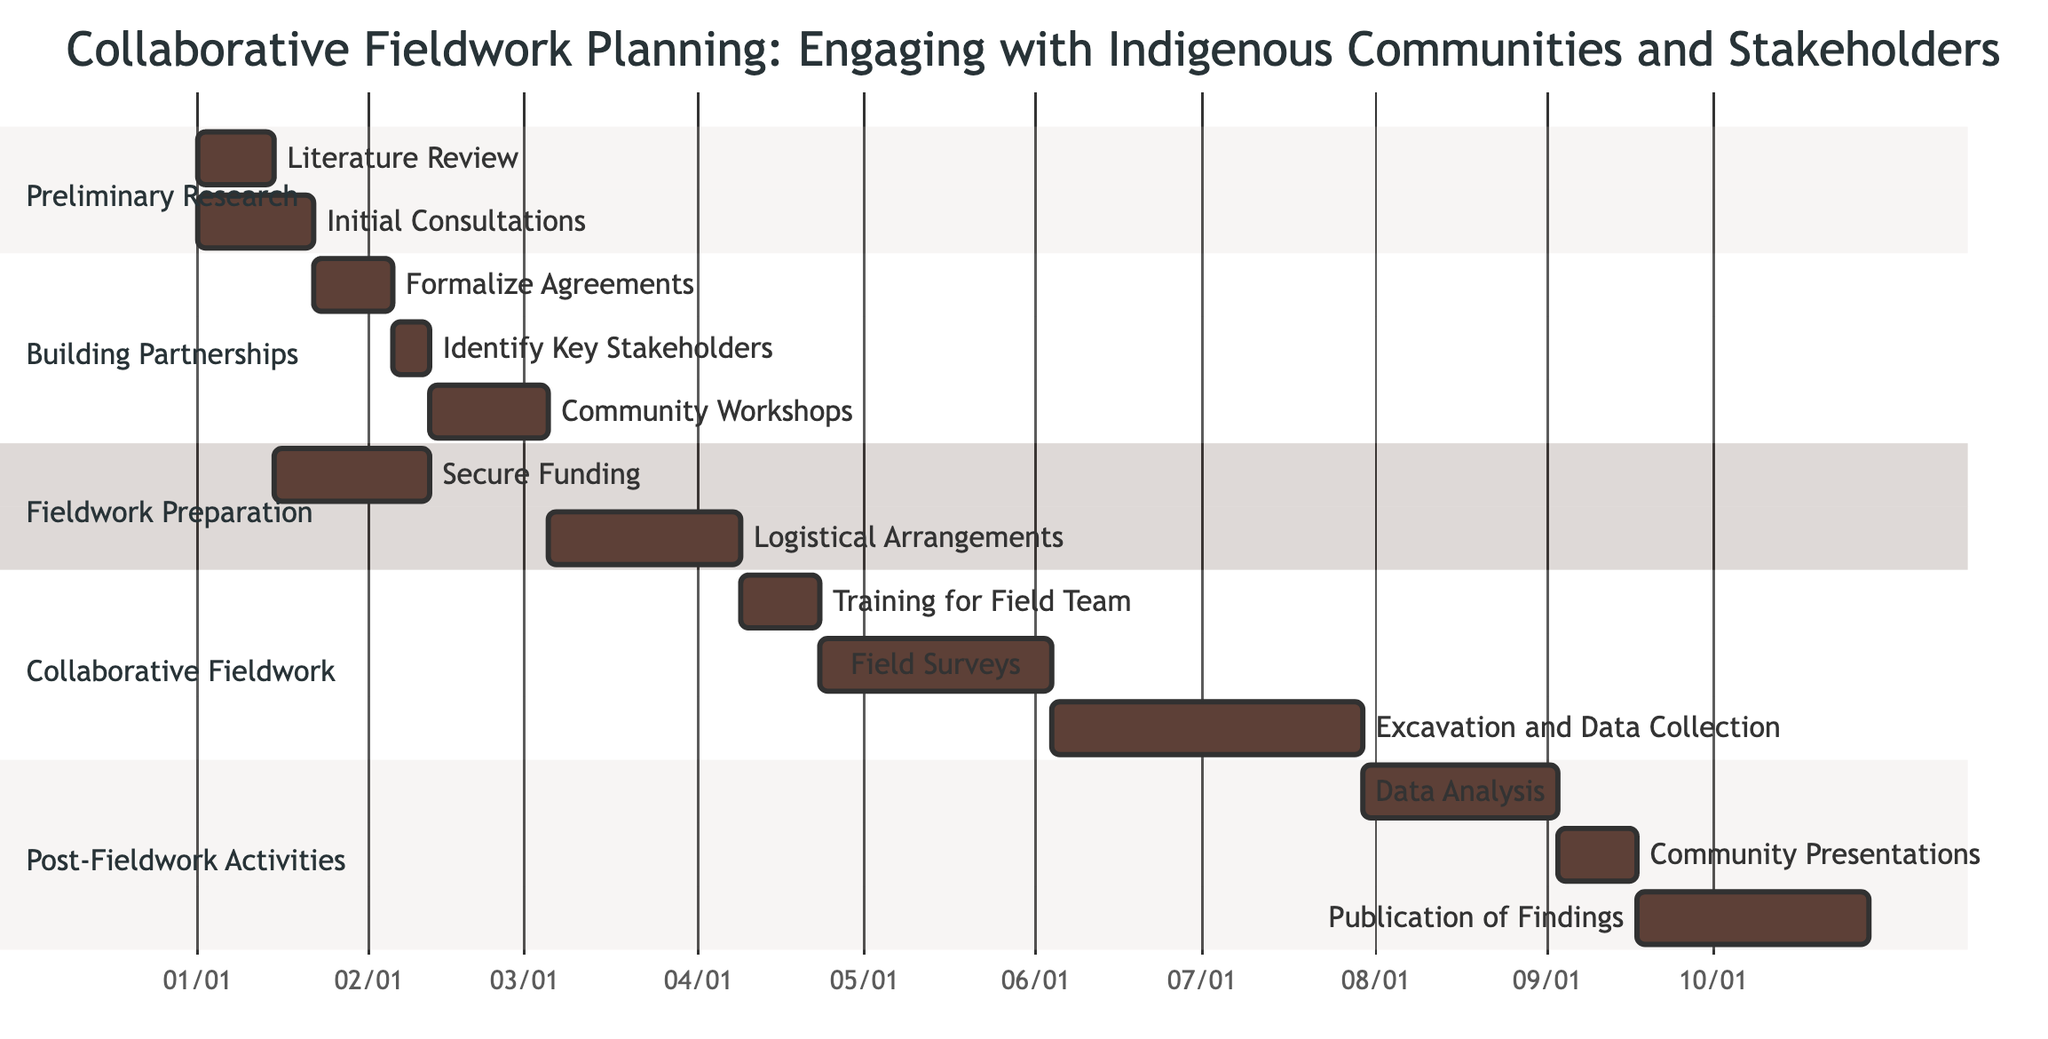What is the duration of the "Community Workshops"? The diagram indicates that "Community Workshops" lasts for 3 weeks, as is directly labeled in the tasks for the "Building Partnerships" section.
Answer: 3 weeks What task follows "Initial Consultations with Community Leaders"? The task "Formalize Agreements" follows after "Initial Consultations with Community Leaders", as per the dependencies noted in the "Building Partnerships" section.
Answer: Formalize Agreements How many weeks is the "Field Surveys" task scheduled to last? According to the Gantt chart, the "Field Surveys" task is scheduled to last for 6 weeks, as mentioned under the "Collaborative Fieldwork" section.
Answer: 6 weeks What is the dependency for "Logistical Arrangements"? "Logistical Arrangements" depends on "Secure Funding" and "Community Workshops", as seen in "Fieldwork Preparation" where both tasks are indicated as prerequisites.
Answer: Secure Funding, Community Workshops What is the total duration of the "Post-Fieldwork Activities" section? The total duration can be calculated by adding the durations of each task in that section: Data Analysis (5 weeks) + Community Presentations (2 weeks) + Publication of Findings (6 weeks) = 13 weeks.
Answer: 13 weeks What tasks are dependent on "Data Analysis"? "Community Presentations" is the only task that is dependent on "Data Analysis" as indicated in the "Post-Fieldwork Activities" section.
Answer: Community Presentations Which task has the longest duration in the entire chart? The "Excavation and Data Collection" task has the longest duration at 8 weeks, as outlined in the "Collaborative Fieldwork" section.
Answer: Excavation and Data Collection When does training for the field team begin? Training for the field team starts after the completion of "Logistical Arrangements", which takes a total of 5 weeks following its dependencies of securing funding and community workshops.
Answer: After Logistical Arrangements What section does "Identify Key Stakeholders" belong to? The task "Identify Key Stakeholders" is part of the "Building Partnerships" section, which is indicated in the diagram layout signifying its thematic organization.
Answer: Building Partnerships 